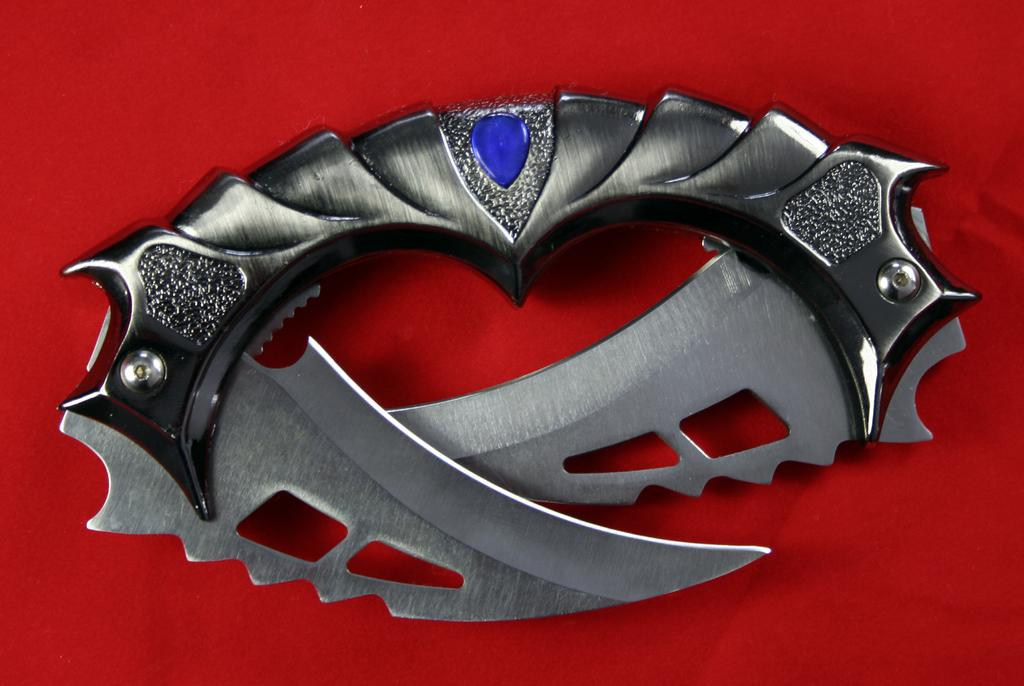What object is present in the image that can be used for cutting? There is a knife present in the image that can be used for cutting. What material is the handle of the knife made of? The handle of the knife is made of iron metal. What type of accessory is attached to the knife's handle? There is a blue color locket on the knife's handle. On what surface is the knife placed in the image? The knife is placed on a red color sheet. Can you tell me how many giants are visible in the image? There are no giants present in the image. What type of grass can be seen growing around the knife in the image? There is no grass visible in the image; the knife is placed on a red color sheet. 